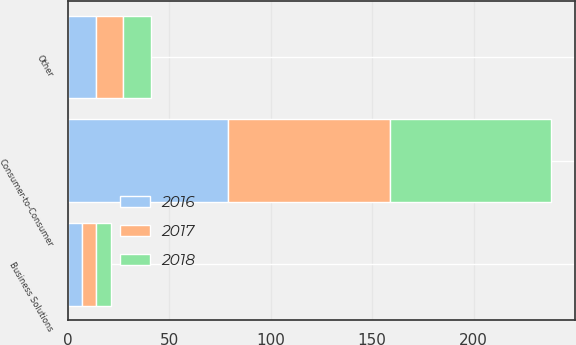Convert chart. <chart><loc_0><loc_0><loc_500><loc_500><stacked_bar_chart><ecel><fcel>Consumer-to-Consumer<fcel>Business Solutions<fcel>Other<nl><fcel>2017<fcel>80<fcel>7<fcel>13<nl><fcel>2016<fcel>79<fcel>7<fcel>14<nl><fcel>2018<fcel>79<fcel>7<fcel>14<nl></chart> 